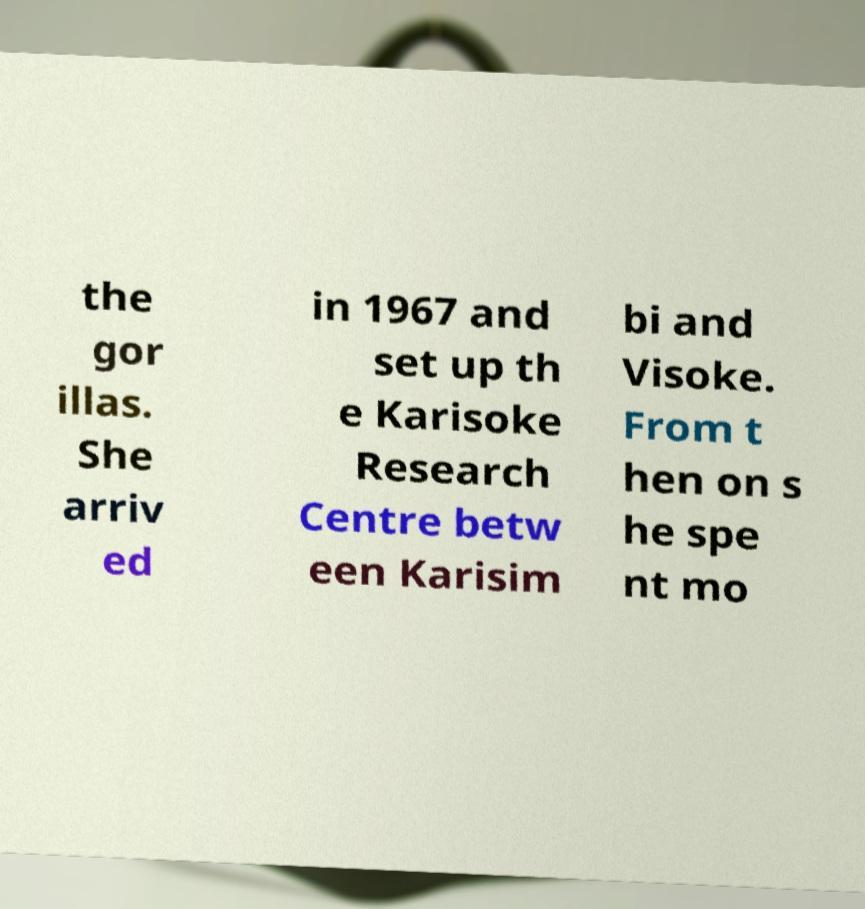Please identify and transcribe the text found in this image. the gor illas. She arriv ed in 1967 and set up th e Karisoke Research Centre betw een Karisim bi and Visoke. From t hen on s he spe nt mo 